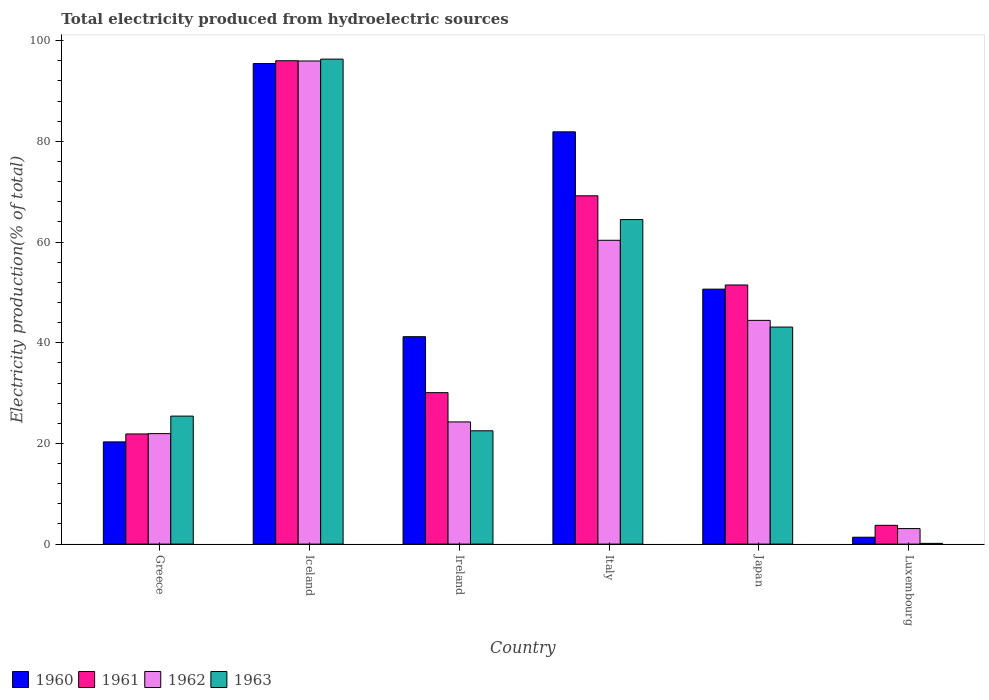How many different coloured bars are there?
Give a very brief answer. 4. Are the number of bars per tick equal to the number of legend labels?
Provide a short and direct response. Yes. Are the number of bars on each tick of the X-axis equal?
Keep it short and to the point. Yes. How many bars are there on the 2nd tick from the left?
Give a very brief answer. 4. How many bars are there on the 3rd tick from the right?
Your response must be concise. 4. In how many cases, is the number of bars for a given country not equal to the number of legend labels?
Keep it short and to the point. 0. What is the total electricity produced in 1960 in Italy?
Offer a terse response. 81.9. Across all countries, what is the maximum total electricity produced in 1962?
Ensure brevity in your answer.  95.97. Across all countries, what is the minimum total electricity produced in 1961?
Ensure brevity in your answer.  3.73. In which country was the total electricity produced in 1960 minimum?
Make the answer very short. Luxembourg. What is the total total electricity produced in 1961 in the graph?
Offer a terse response. 272.39. What is the difference between the total electricity produced in 1960 in Greece and that in Luxembourg?
Keep it short and to the point. 18.94. What is the difference between the total electricity produced in 1961 in Italy and the total electricity produced in 1960 in Luxembourg?
Make the answer very short. 67.82. What is the average total electricity produced in 1962 per country?
Provide a succinct answer. 41.68. What is the difference between the total electricity produced of/in 1960 and total electricity produced of/in 1961 in Japan?
Your answer should be very brief. -0.83. In how many countries, is the total electricity produced in 1960 greater than 68 %?
Provide a succinct answer. 2. What is the ratio of the total electricity produced in 1962 in Iceland to that in Japan?
Give a very brief answer. 2.16. Is the difference between the total electricity produced in 1960 in Ireland and Japan greater than the difference between the total electricity produced in 1961 in Ireland and Japan?
Keep it short and to the point. Yes. What is the difference between the highest and the second highest total electricity produced in 1963?
Give a very brief answer. 53.23. What is the difference between the highest and the lowest total electricity produced in 1963?
Ensure brevity in your answer.  96.19. In how many countries, is the total electricity produced in 1961 greater than the average total electricity produced in 1961 taken over all countries?
Your answer should be very brief. 3. Is the sum of the total electricity produced in 1962 in Iceland and Luxembourg greater than the maximum total electricity produced in 1963 across all countries?
Make the answer very short. Yes. What does the 3rd bar from the right in Japan represents?
Your answer should be compact. 1961. How many bars are there?
Your response must be concise. 24. Are all the bars in the graph horizontal?
Offer a terse response. No. What is the difference between two consecutive major ticks on the Y-axis?
Provide a succinct answer. 20. Are the values on the major ticks of Y-axis written in scientific E-notation?
Offer a very short reply. No. Does the graph contain grids?
Keep it short and to the point. No. Where does the legend appear in the graph?
Your response must be concise. Bottom left. How are the legend labels stacked?
Your response must be concise. Horizontal. What is the title of the graph?
Your answer should be very brief. Total electricity produced from hydroelectric sources. Does "1963" appear as one of the legend labels in the graph?
Your response must be concise. Yes. What is the label or title of the Y-axis?
Your answer should be very brief. Electricity production(% of total). What is the Electricity production(% of total) of 1960 in Greece?
Provide a short and direct response. 20.31. What is the Electricity production(% of total) of 1961 in Greece?
Provide a succinct answer. 21.88. What is the Electricity production(% of total) of 1962 in Greece?
Make the answer very short. 21.95. What is the Electricity production(% of total) in 1963 in Greece?
Offer a terse response. 25.43. What is the Electricity production(% of total) of 1960 in Iceland?
Provide a succinct answer. 95.46. What is the Electricity production(% of total) of 1961 in Iceland?
Offer a terse response. 96.02. What is the Electricity production(% of total) of 1962 in Iceland?
Give a very brief answer. 95.97. What is the Electricity production(% of total) of 1963 in Iceland?
Your answer should be very brief. 96.34. What is the Electricity production(% of total) of 1960 in Ireland?
Your response must be concise. 41.2. What is the Electricity production(% of total) of 1961 in Ireland?
Your answer should be compact. 30.09. What is the Electricity production(% of total) in 1962 in Ireland?
Make the answer very short. 24.27. What is the Electricity production(% of total) of 1963 in Ireland?
Ensure brevity in your answer.  22.51. What is the Electricity production(% of total) of 1960 in Italy?
Your answer should be compact. 81.9. What is the Electricity production(% of total) in 1961 in Italy?
Offer a very short reply. 69.19. What is the Electricity production(% of total) in 1962 in Italy?
Offer a terse response. 60.35. What is the Electricity production(% of total) in 1963 in Italy?
Provide a succinct answer. 64.47. What is the Electricity production(% of total) of 1960 in Japan?
Your answer should be very brief. 50.65. What is the Electricity production(% of total) in 1961 in Japan?
Your answer should be very brief. 51.48. What is the Electricity production(% of total) in 1962 in Japan?
Keep it short and to the point. 44.44. What is the Electricity production(% of total) in 1963 in Japan?
Provide a succinct answer. 43.11. What is the Electricity production(% of total) in 1960 in Luxembourg?
Your answer should be compact. 1.37. What is the Electricity production(% of total) in 1961 in Luxembourg?
Provide a short and direct response. 3.73. What is the Electricity production(% of total) in 1962 in Luxembourg?
Offer a very short reply. 3.08. What is the Electricity production(% of total) of 1963 in Luxembourg?
Provide a short and direct response. 0.15. Across all countries, what is the maximum Electricity production(% of total) in 1960?
Offer a very short reply. 95.46. Across all countries, what is the maximum Electricity production(% of total) in 1961?
Offer a very short reply. 96.02. Across all countries, what is the maximum Electricity production(% of total) of 1962?
Your response must be concise. 95.97. Across all countries, what is the maximum Electricity production(% of total) of 1963?
Your answer should be compact. 96.34. Across all countries, what is the minimum Electricity production(% of total) in 1960?
Provide a succinct answer. 1.37. Across all countries, what is the minimum Electricity production(% of total) of 1961?
Provide a succinct answer. 3.73. Across all countries, what is the minimum Electricity production(% of total) of 1962?
Give a very brief answer. 3.08. Across all countries, what is the minimum Electricity production(% of total) of 1963?
Provide a succinct answer. 0.15. What is the total Electricity production(% of total) in 1960 in the graph?
Make the answer very short. 290.89. What is the total Electricity production(% of total) in 1961 in the graph?
Offer a terse response. 272.39. What is the total Electricity production(% of total) of 1962 in the graph?
Keep it short and to the point. 250.08. What is the total Electricity production(% of total) in 1963 in the graph?
Your response must be concise. 252.01. What is the difference between the Electricity production(% of total) of 1960 in Greece and that in Iceland?
Your answer should be very brief. -75.16. What is the difference between the Electricity production(% of total) of 1961 in Greece and that in Iceland?
Offer a terse response. -74.14. What is the difference between the Electricity production(% of total) of 1962 in Greece and that in Iceland?
Your answer should be very brief. -74.02. What is the difference between the Electricity production(% of total) of 1963 in Greece and that in Iceland?
Keep it short and to the point. -70.91. What is the difference between the Electricity production(% of total) in 1960 in Greece and that in Ireland?
Offer a terse response. -20.9. What is the difference between the Electricity production(% of total) of 1961 in Greece and that in Ireland?
Keep it short and to the point. -8.2. What is the difference between the Electricity production(% of total) in 1962 in Greece and that in Ireland?
Your answer should be compact. -2.32. What is the difference between the Electricity production(% of total) in 1963 in Greece and that in Ireland?
Your answer should be very brief. 2.92. What is the difference between the Electricity production(% of total) in 1960 in Greece and that in Italy?
Provide a short and direct response. -61.59. What is the difference between the Electricity production(% of total) of 1961 in Greece and that in Italy?
Your answer should be compact. -47.31. What is the difference between the Electricity production(% of total) in 1962 in Greece and that in Italy?
Keep it short and to the point. -38.4. What is the difference between the Electricity production(% of total) of 1963 in Greece and that in Italy?
Provide a succinct answer. -39.04. What is the difference between the Electricity production(% of total) of 1960 in Greece and that in Japan?
Make the answer very short. -30.34. What is the difference between the Electricity production(% of total) in 1961 in Greece and that in Japan?
Provide a short and direct response. -29.59. What is the difference between the Electricity production(% of total) in 1962 in Greece and that in Japan?
Make the answer very short. -22.49. What is the difference between the Electricity production(% of total) of 1963 in Greece and that in Japan?
Give a very brief answer. -17.69. What is the difference between the Electricity production(% of total) in 1960 in Greece and that in Luxembourg?
Offer a very short reply. 18.94. What is the difference between the Electricity production(% of total) in 1961 in Greece and that in Luxembourg?
Your response must be concise. 18.15. What is the difference between the Electricity production(% of total) of 1962 in Greece and that in Luxembourg?
Ensure brevity in your answer.  18.87. What is the difference between the Electricity production(% of total) of 1963 in Greece and that in Luxembourg?
Offer a terse response. 25.28. What is the difference between the Electricity production(% of total) in 1960 in Iceland and that in Ireland?
Your answer should be very brief. 54.26. What is the difference between the Electricity production(% of total) of 1961 in Iceland and that in Ireland?
Make the answer very short. 65.93. What is the difference between the Electricity production(% of total) of 1962 in Iceland and that in Ireland?
Your answer should be compact. 71.7. What is the difference between the Electricity production(% of total) of 1963 in Iceland and that in Ireland?
Your answer should be very brief. 73.83. What is the difference between the Electricity production(% of total) in 1960 in Iceland and that in Italy?
Ensure brevity in your answer.  13.56. What is the difference between the Electricity production(% of total) of 1961 in Iceland and that in Italy?
Offer a terse response. 26.83. What is the difference between the Electricity production(% of total) of 1962 in Iceland and that in Italy?
Your answer should be compact. 35.62. What is the difference between the Electricity production(% of total) in 1963 in Iceland and that in Italy?
Your answer should be compact. 31.87. What is the difference between the Electricity production(% of total) of 1960 in Iceland and that in Japan?
Give a very brief answer. 44.81. What is the difference between the Electricity production(% of total) of 1961 in Iceland and that in Japan?
Provide a short and direct response. 44.54. What is the difference between the Electricity production(% of total) of 1962 in Iceland and that in Japan?
Your answer should be compact. 51.53. What is the difference between the Electricity production(% of total) of 1963 in Iceland and that in Japan?
Give a very brief answer. 53.23. What is the difference between the Electricity production(% of total) in 1960 in Iceland and that in Luxembourg?
Provide a short and direct response. 94.1. What is the difference between the Electricity production(% of total) in 1961 in Iceland and that in Luxembourg?
Your answer should be compact. 92.29. What is the difference between the Electricity production(% of total) in 1962 in Iceland and that in Luxembourg?
Ensure brevity in your answer.  92.89. What is the difference between the Electricity production(% of total) of 1963 in Iceland and that in Luxembourg?
Provide a short and direct response. 96.19. What is the difference between the Electricity production(% of total) of 1960 in Ireland and that in Italy?
Offer a very short reply. -40.7. What is the difference between the Electricity production(% of total) of 1961 in Ireland and that in Italy?
Keep it short and to the point. -39.1. What is the difference between the Electricity production(% of total) of 1962 in Ireland and that in Italy?
Provide a succinct answer. -36.08. What is the difference between the Electricity production(% of total) in 1963 in Ireland and that in Italy?
Keep it short and to the point. -41.96. What is the difference between the Electricity production(% of total) of 1960 in Ireland and that in Japan?
Your response must be concise. -9.45. What is the difference between the Electricity production(% of total) of 1961 in Ireland and that in Japan?
Provide a short and direct response. -21.39. What is the difference between the Electricity production(% of total) of 1962 in Ireland and that in Japan?
Offer a terse response. -20.17. What is the difference between the Electricity production(% of total) in 1963 in Ireland and that in Japan?
Make the answer very short. -20.61. What is the difference between the Electricity production(% of total) in 1960 in Ireland and that in Luxembourg?
Offer a terse response. 39.84. What is the difference between the Electricity production(% of total) of 1961 in Ireland and that in Luxembourg?
Your answer should be very brief. 26.36. What is the difference between the Electricity production(% of total) of 1962 in Ireland and that in Luxembourg?
Your answer should be compact. 21.19. What is the difference between the Electricity production(% of total) in 1963 in Ireland and that in Luxembourg?
Make the answer very short. 22.36. What is the difference between the Electricity production(% of total) in 1960 in Italy and that in Japan?
Make the answer very short. 31.25. What is the difference between the Electricity production(% of total) in 1961 in Italy and that in Japan?
Provide a succinct answer. 17.71. What is the difference between the Electricity production(% of total) of 1962 in Italy and that in Japan?
Offer a terse response. 15.91. What is the difference between the Electricity production(% of total) of 1963 in Italy and that in Japan?
Make the answer very short. 21.35. What is the difference between the Electricity production(% of total) of 1960 in Italy and that in Luxembourg?
Your answer should be compact. 80.53. What is the difference between the Electricity production(% of total) of 1961 in Italy and that in Luxembourg?
Your answer should be compact. 65.46. What is the difference between the Electricity production(% of total) of 1962 in Italy and that in Luxembourg?
Your response must be concise. 57.27. What is the difference between the Electricity production(% of total) of 1963 in Italy and that in Luxembourg?
Make the answer very short. 64.32. What is the difference between the Electricity production(% of total) of 1960 in Japan and that in Luxembourg?
Keep it short and to the point. 49.28. What is the difference between the Electricity production(% of total) in 1961 in Japan and that in Luxembourg?
Ensure brevity in your answer.  47.75. What is the difference between the Electricity production(% of total) in 1962 in Japan and that in Luxembourg?
Provide a short and direct response. 41.36. What is the difference between the Electricity production(% of total) in 1963 in Japan and that in Luxembourg?
Offer a very short reply. 42.97. What is the difference between the Electricity production(% of total) in 1960 in Greece and the Electricity production(% of total) in 1961 in Iceland?
Ensure brevity in your answer.  -75.71. What is the difference between the Electricity production(% of total) in 1960 in Greece and the Electricity production(% of total) in 1962 in Iceland?
Offer a terse response. -75.67. What is the difference between the Electricity production(% of total) in 1960 in Greece and the Electricity production(% of total) in 1963 in Iceland?
Your answer should be very brief. -76.04. What is the difference between the Electricity production(% of total) of 1961 in Greece and the Electricity production(% of total) of 1962 in Iceland?
Offer a very short reply. -74.09. What is the difference between the Electricity production(% of total) of 1961 in Greece and the Electricity production(% of total) of 1963 in Iceland?
Provide a short and direct response. -74.46. What is the difference between the Electricity production(% of total) of 1962 in Greece and the Electricity production(% of total) of 1963 in Iceland?
Give a very brief answer. -74.39. What is the difference between the Electricity production(% of total) in 1960 in Greece and the Electricity production(% of total) in 1961 in Ireland?
Give a very brief answer. -9.78. What is the difference between the Electricity production(% of total) of 1960 in Greece and the Electricity production(% of total) of 1962 in Ireland?
Provide a short and direct response. -3.97. What is the difference between the Electricity production(% of total) of 1960 in Greece and the Electricity production(% of total) of 1963 in Ireland?
Offer a terse response. -2.2. What is the difference between the Electricity production(% of total) of 1961 in Greece and the Electricity production(% of total) of 1962 in Ireland?
Offer a very short reply. -2.39. What is the difference between the Electricity production(% of total) in 1961 in Greece and the Electricity production(% of total) in 1963 in Ireland?
Your response must be concise. -0.63. What is the difference between the Electricity production(% of total) in 1962 in Greece and the Electricity production(% of total) in 1963 in Ireland?
Provide a short and direct response. -0.56. What is the difference between the Electricity production(% of total) in 1960 in Greece and the Electricity production(% of total) in 1961 in Italy?
Offer a very short reply. -48.88. What is the difference between the Electricity production(% of total) of 1960 in Greece and the Electricity production(% of total) of 1962 in Italy?
Your answer should be compact. -40.05. What is the difference between the Electricity production(% of total) of 1960 in Greece and the Electricity production(% of total) of 1963 in Italy?
Give a very brief answer. -44.16. What is the difference between the Electricity production(% of total) of 1961 in Greece and the Electricity production(% of total) of 1962 in Italy?
Ensure brevity in your answer.  -38.47. What is the difference between the Electricity production(% of total) of 1961 in Greece and the Electricity production(% of total) of 1963 in Italy?
Give a very brief answer. -42.58. What is the difference between the Electricity production(% of total) of 1962 in Greece and the Electricity production(% of total) of 1963 in Italy?
Offer a terse response. -42.52. What is the difference between the Electricity production(% of total) in 1960 in Greece and the Electricity production(% of total) in 1961 in Japan?
Your response must be concise. -31.17. What is the difference between the Electricity production(% of total) of 1960 in Greece and the Electricity production(% of total) of 1962 in Japan?
Keep it short and to the point. -24.14. What is the difference between the Electricity production(% of total) of 1960 in Greece and the Electricity production(% of total) of 1963 in Japan?
Offer a terse response. -22.81. What is the difference between the Electricity production(% of total) in 1961 in Greece and the Electricity production(% of total) in 1962 in Japan?
Provide a succinct answer. -22.56. What is the difference between the Electricity production(% of total) of 1961 in Greece and the Electricity production(% of total) of 1963 in Japan?
Keep it short and to the point. -21.23. What is the difference between the Electricity production(% of total) in 1962 in Greece and the Electricity production(% of total) in 1963 in Japan?
Provide a short and direct response. -21.16. What is the difference between the Electricity production(% of total) of 1960 in Greece and the Electricity production(% of total) of 1961 in Luxembourg?
Your response must be concise. 16.58. What is the difference between the Electricity production(% of total) of 1960 in Greece and the Electricity production(% of total) of 1962 in Luxembourg?
Make the answer very short. 17.22. What is the difference between the Electricity production(% of total) in 1960 in Greece and the Electricity production(% of total) in 1963 in Luxembourg?
Provide a short and direct response. 20.16. What is the difference between the Electricity production(% of total) of 1961 in Greece and the Electricity production(% of total) of 1962 in Luxembourg?
Your answer should be compact. 18.8. What is the difference between the Electricity production(% of total) of 1961 in Greece and the Electricity production(% of total) of 1963 in Luxembourg?
Your answer should be very brief. 21.74. What is the difference between the Electricity production(% of total) of 1962 in Greece and the Electricity production(% of total) of 1963 in Luxembourg?
Your answer should be compact. 21.8. What is the difference between the Electricity production(% of total) in 1960 in Iceland and the Electricity production(% of total) in 1961 in Ireland?
Provide a succinct answer. 65.38. What is the difference between the Electricity production(% of total) in 1960 in Iceland and the Electricity production(% of total) in 1962 in Ireland?
Your response must be concise. 71.19. What is the difference between the Electricity production(% of total) of 1960 in Iceland and the Electricity production(% of total) of 1963 in Ireland?
Your answer should be compact. 72.95. What is the difference between the Electricity production(% of total) of 1961 in Iceland and the Electricity production(% of total) of 1962 in Ireland?
Ensure brevity in your answer.  71.75. What is the difference between the Electricity production(% of total) of 1961 in Iceland and the Electricity production(% of total) of 1963 in Ireland?
Offer a very short reply. 73.51. What is the difference between the Electricity production(% of total) in 1962 in Iceland and the Electricity production(% of total) in 1963 in Ireland?
Keep it short and to the point. 73.47. What is the difference between the Electricity production(% of total) in 1960 in Iceland and the Electricity production(% of total) in 1961 in Italy?
Your answer should be compact. 26.27. What is the difference between the Electricity production(% of total) in 1960 in Iceland and the Electricity production(% of total) in 1962 in Italy?
Keep it short and to the point. 35.11. What is the difference between the Electricity production(% of total) of 1960 in Iceland and the Electricity production(% of total) of 1963 in Italy?
Provide a succinct answer. 30.99. What is the difference between the Electricity production(% of total) in 1961 in Iceland and the Electricity production(% of total) in 1962 in Italy?
Give a very brief answer. 35.67. What is the difference between the Electricity production(% of total) of 1961 in Iceland and the Electricity production(% of total) of 1963 in Italy?
Offer a terse response. 31.55. What is the difference between the Electricity production(% of total) in 1962 in Iceland and the Electricity production(% of total) in 1963 in Italy?
Ensure brevity in your answer.  31.51. What is the difference between the Electricity production(% of total) of 1960 in Iceland and the Electricity production(% of total) of 1961 in Japan?
Keep it short and to the point. 43.99. What is the difference between the Electricity production(% of total) in 1960 in Iceland and the Electricity production(% of total) in 1962 in Japan?
Make the answer very short. 51.02. What is the difference between the Electricity production(% of total) of 1960 in Iceland and the Electricity production(% of total) of 1963 in Japan?
Your answer should be compact. 52.35. What is the difference between the Electricity production(% of total) in 1961 in Iceland and the Electricity production(% of total) in 1962 in Japan?
Provide a succinct answer. 51.58. What is the difference between the Electricity production(% of total) of 1961 in Iceland and the Electricity production(% of total) of 1963 in Japan?
Make the answer very short. 52.91. What is the difference between the Electricity production(% of total) of 1962 in Iceland and the Electricity production(% of total) of 1963 in Japan?
Your response must be concise. 52.86. What is the difference between the Electricity production(% of total) in 1960 in Iceland and the Electricity production(% of total) in 1961 in Luxembourg?
Your answer should be compact. 91.73. What is the difference between the Electricity production(% of total) of 1960 in Iceland and the Electricity production(% of total) of 1962 in Luxembourg?
Offer a terse response. 92.38. What is the difference between the Electricity production(% of total) of 1960 in Iceland and the Electricity production(% of total) of 1963 in Luxembourg?
Keep it short and to the point. 95.32. What is the difference between the Electricity production(% of total) in 1961 in Iceland and the Electricity production(% of total) in 1962 in Luxembourg?
Ensure brevity in your answer.  92.94. What is the difference between the Electricity production(% of total) in 1961 in Iceland and the Electricity production(% of total) in 1963 in Luxembourg?
Ensure brevity in your answer.  95.87. What is the difference between the Electricity production(% of total) of 1962 in Iceland and the Electricity production(% of total) of 1963 in Luxembourg?
Keep it short and to the point. 95.83. What is the difference between the Electricity production(% of total) in 1960 in Ireland and the Electricity production(% of total) in 1961 in Italy?
Provide a succinct answer. -27.99. What is the difference between the Electricity production(% of total) of 1960 in Ireland and the Electricity production(% of total) of 1962 in Italy?
Give a very brief answer. -19.15. What is the difference between the Electricity production(% of total) in 1960 in Ireland and the Electricity production(% of total) in 1963 in Italy?
Offer a terse response. -23.27. What is the difference between the Electricity production(% of total) of 1961 in Ireland and the Electricity production(% of total) of 1962 in Italy?
Ensure brevity in your answer.  -30.27. What is the difference between the Electricity production(% of total) in 1961 in Ireland and the Electricity production(% of total) in 1963 in Italy?
Provide a succinct answer. -34.38. What is the difference between the Electricity production(% of total) in 1962 in Ireland and the Electricity production(% of total) in 1963 in Italy?
Your answer should be very brief. -40.2. What is the difference between the Electricity production(% of total) in 1960 in Ireland and the Electricity production(% of total) in 1961 in Japan?
Offer a very short reply. -10.27. What is the difference between the Electricity production(% of total) in 1960 in Ireland and the Electricity production(% of total) in 1962 in Japan?
Provide a short and direct response. -3.24. What is the difference between the Electricity production(% of total) of 1960 in Ireland and the Electricity production(% of total) of 1963 in Japan?
Offer a very short reply. -1.91. What is the difference between the Electricity production(% of total) in 1961 in Ireland and the Electricity production(% of total) in 1962 in Japan?
Your answer should be very brief. -14.36. What is the difference between the Electricity production(% of total) in 1961 in Ireland and the Electricity production(% of total) in 1963 in Japan?
Provide a short and direct response. -13.03. What is the difference between the Electricity production(% of total) in 1962 in Ireland and the Electricity production(% of total) in 1963 in Japan?
Give a very brief answer. -18.84. What is the difference between the Electricity production(% of total) of 1960 in Ireland and the Electricity production(% of total) of 1961 in Luxembourg?
Ensure brevity in your answer.  37.47. What is the difference between the Electricity production(% of total) of 1960 in Ireland and the Electricity production(% of total) of 1962 in Luxembourg?
Ensure brevity in your answer.  38.12. What is the difference between the Electricity production(% of total) in 1960 in Ireland and the Electricity production(% of total) in 1963 in Luxembourg?
Ensure brevity in your answer.  41.05. What is the difference between the Electricity production(% of total) of 1961 in Ireland and the Electricity production(% of total) of 1962 in Luxembourg?
Ensure brevity in your answer.  27. What is the difference between the Electricity production(% of total) in 1961 in Ireland and the Electricity production(% of total) in 1963 in Luxembourg?
Keep it short and to the point. 29.94. What is the difference between the Electricity production(% of total) in 1962 in Ireland and the Electricity production(% of total) in 1963 in Luxembourg?
Offer a very short reply. 24.12. What is the difference between the Electricity production(% of total) of 1960 in Italy and the Electricity production(% of total) of 1961 in Japan?
Your answer should be compact. 30.42. What is the difference between the Electricity production(% of total) of 1960 in Italy and the Electricity production(% of total) of 1962 in Japan?
Make the answer very short. 37.46. What is the difference between the Electricity production(% of total) of 1960 in Italy and the Electricity production(% of total) of 1963 in Japan?
Your answer should be compact. 38.79. What is the difference between the Electricity production(% of total) in 1961 in Italy and the Electricity production(% of total) in 1962 in Japan?
Your response must be concise. 24.75. What is the difference between the Electricity production(% of total) of 1961 in Italy and the Electricity production(% of total) of 1963 in Japan?
Your answer should be compact. 26.08. What is the difference between the Electricity production(% of total) of 1962 in Italy and the Electricity production(% of total) of 1963 in Japan?
Offer a very short reply. 17.24. What is the difference between the Electricity production(% of total) of 1960 in Italy and the Electricity production(% of total) of 1961 in Luxembourg?
Your response must be concise. 78.17. What is the difference between the Electricity production(% of total) in 1960 in Italy and the Electricity production(% of total) in 1962 in Luxembourg?
Your response must be concise. 78.82. What is the difference between the Electricity production(% of total) of 1960 in Italy and the Electricity production(% of total) of 1963 in Luxembourg?
Your answer should be compact. 81.75. What is the difference between the Electricity production(% of total) of 1961 in Italy and the Electricity production(% of total) of 1962 in Luxembourg?
Give a very brief answer. 66.11. What is the difference between the Electricity production(% of total) of 1961 in Italy and the Electricity production(% of total) of 1963 in Luxembourg?
Your answer should be very brief. 69.04. What is the difference between the Electricity production(% of total) of 1962 in Italy and the Electricity production(% of total) of 1963 in Luxembourg?
Your answer should be very brief. 60.21. What is the difference between the Electricity production(% of total) in 1960 in Japan and the Electricity production(% of total) in 1961 in Luxembourg?
Your answer should be compact. 46.92. What is the difference between the Electricity production(% of total) of 1960 in Japan and the Electricity production(% of total) of 1962 in Luxembourg?
Your response must be concise. 47.57. What is the difference between the Electricity production(% of total) of 1960 in Japan and the Electricity production(% of total) of 1963 in Luxembourg?
Your answer should be very brief. 50.5. What is the difference between the Electricity production(% of total) of 1961 in Japan and the Electricity production(% of total) of 1962 in Luxembourg?
Keep it short and to the point. 48.39. What is the difference between the Electricity production(% of total) in 1961 in Japan and the Electricity production(% of total) in 1963 in Luxembourg?
Your response must be concise. 51.33. What is the difference between the Electricity production(% of total) of 1962 in Japan and the Electricity production(% of total) of 1963 in Luxembourg?
Give a very brief answer. 44.3. What is the average Electricity production(% of total) in 1960 per country?
Your response must be concise. 48.48. What is the average Electricity production(% of total) in 1961 per country?
Make the answer very short. 45.4. What is the average Electricity production(% of total) in 1962 per country?
Give a very brief answer. 41.68. What is the average Electricity production(% of total) of 1963 per country?
Your response must be concise. 42. What is the difference between the Electricity production(% of total) of 1960 and Electricity production(% of total) of 1961 in Greece?
Offer a very short reply. -1.58. What is the difference between the Electricity production(% of total) of 1960 and Electricity production(% of total) of 1962 in Greece?
Ensure brevity in your answer.  -1.64. What is the difference between the Electricity production(% of total) in 1960 and Electricity production(% of total) in 1963 in Greece?
Your response must be concise. -5.12. What is the difference between the Electricity production(% of total) in 1961 and Electricity production(% of total) in 1962 in Greece?
Offer a very short reply. -0.07. What is the difference between the Electricity production(% of total) of 1961 and Electricity production(% of total) of 1963 in Greece?
Offer a terse response. -3.54. What is the difference between the Electricity production(% of total) of 1962 and Electricity production(% of total) of 1963 in Greece?
Provide a short and direct response. -3.48. What is the difference between the Electricity production(% of total) of 1960 and Electricity production(% of total) of 1961 in Iceland?
Your answer should be compact. -0.56. What is the difference between the Electricity production(% of total) in 1960 and Electricity production(% of total) in 1962 in Iceland?
Offer a very short reply. -0.51. What is the difference between the Electricity production(% of total) of 1960 and Electricity production(% of total) of 1963 in Iceland?
Provide a succinct answer. -0.88. What is the difference between the Electricity production(% of total) in 1961 and Electricity production(% of total) in 1962 in Iceland?
Offer a terse response. 0.05. What is the difference between the Electricity production(% of total) in 1961 and Electricity production(% of total) in 1963 in Iceland?
Make the answer very short. -0.32. What is the difference between the Electricity production(% of total) in 1962 and Electricity production(% of total) in 1963 in Iceland?
Offer a very short reply. -0.37. What is the difference between the Electricity production(% of total) in 1960 and Electricity production(% of total) in 1961 in Ireland?
Provide a succinct answer. 11.12. What is the difference between the Electricity production(% of total) in 1960 and Electricity production(% of total) in 1962 in Ireland?
Give a very brief answer. 16.93. What is the difference between the Electricity production(% of total) of 1960 and Electricity production(% of total) of 1963 in Ireland?
Keep it short and to the point. 18.69. What is the difference between the Electricity production(% of total) in 1961 and Electricity production(% of total) in 1962 in Ireland?
Your answer should be compact. 5.81. What is the difference between the Electricity production(% of total) in 1961 and Electricity production(% of total) in 1963 in Ireland?
Give a very brief answer. 7.58. What is the difference between the Electricity production(% of total) of 1962 and Electricity production(% of total) of 1963 in Ireland?
Provide a succinct answer. 1.76. What is the difference between the Electricity production(% of total) of 1960 and Electricity production(% of total) of 1961 in Italy?
Your response must be concise. 12.71. What is the difference between the Electricity production(% of total) in 1960 and Electricity production(% of total) in 1962 in Italy?
Offer a terse response. 21.55. What is the difference between the Electricity production(% of total) of 1960 and Electricity production(% of total) of 1963 in Italy?
Keep it short and to the point. 17.43. What is the difference between the Electricity production(% of total) of 1961 and Electricity production(% of total) of 1962 in Italy?
Ensure brevity in your answer.  8.84. What is the difference between the Electricity production(% of total) in 1961 and Electricity production(% of total) in 1963 in Italy?
Offer a terse response. 4.72. What is the difference between the Electricity production(% of total) in 1962 and Electricity production(% of total) in 1963 in Italy?
Provide a short and direct response. -4.11. What is the difference between the Electricity production(% of total) of 1960 and Electricity production(% of total) of 1961 in Japan?
Make the answer very short. -0.83. What is the difference between the Electricity production(% of total) in 1960 and Electricity production(% of total) in 1962 in Japan?
Offer a very short reply. 6.2. What is the difference between the Electricity production(% of total) in 1960 and Electricity production(% of total) in 1963 in Japan?
Keep it short and to the point. 7.54. What is the difference between the Electricity production(% of total) in 1961 and Electricity production(% of total) in 1962 in Japan?
Your answer should be very brief. 7.03. What is the difference between the Electricity production(% of total) of 1961 and Electricity production(% of total) of 1963 in Japan?
Make the answer very short. 8.36. What is the difference between the Electricity production(% of total) of 1962 and Electricity production(% of total) of 1963 in Japan?
Offer a very short reply. 1.33. What is the difference between the Electricity production(% of total) in 1960 and Electricity production(% of total) in 1961 in Luxembourg?
Offer a very short reply. -2.36. What is the difference between the Electricity production(% of total) in 1960 and Electricity production(% of total) in 1962 in Luxembourg?
Keep it short and to the point. -1.72. What is the difference between the Electricity production(% of total) in 1960 and Electricity production(% of total) in 1963 in Luxembourg?
Give a very brief answer. 1.22. What is the difference between the Electricity production(% of total) of 1961 and Electricity production(% of total) of 1962 in Luxembourg?
Offer a terse response. 0.65. What is the difference between the Electricity production(% of total) of 1961 and Electricity production(% of total) of 1963 in Luxembourg?
Give a very brief answer. 3.58. What is the difference between the Electricity production(% of total) of 1962 and Electricity production(% of total) of 1963 in Luxembourg?
Provide a succinct answer. 2.93. What is the ratio of the Electricity production(% of total) in 1960 in Greece to that in Iceland?
Offer a terse response. 0.21. What is the ratio of the Electricity production(% of total) of 1961 in Greece to that in Iceland?
Provide a short and direct response. 0.23. What is the ratio of the Electricity production(% of total) in 1962 in Greece to that in Iceland?
Your response must be concise. 0.23. What is the ratio of the Electricity production(% of total) in 1963 in Greece to that in Iceland?
Provide a short and direct response. 0.26. What is the ratio of the Electricity production(% of total) of 1960 in Greece to that in Ireland?
Keep it short and to the point. 0.49. What is the ratio of the Electricity production(% of total) in 1961 in Greece to that in Ireland?
Offer a very short reply. 0.73. What is the ratio of the Electricity production(% of total) in 1962 in Greece to that in Ireland?
Give a very brief answer. 0.9. What is the ratio of the Electricity production(% of total) of 1963 in Greece to that in Ireland?
Offer a terse response. 1.13. What is the ratio of the Electricity production(% of total) of 1960 in Greece to that in Italy?
Provide a succinct answer. 0.25. What is the ratio of the Electricity production(% of total) in 1961 in Greece to that in Italy?
Make the answer very short. 0.32. What is the ratio of the Electricity production(% of total) in 1962 in Greece to that in Italy?
Your answer should be compact. 0.36. What is the ratio of the Electricity production(% of total) of 1963 in Greece to that in Italy?
Keep it short and to the point. 0.39. What is the ratio of the Electricity production(% of total) of 1960 in Greece to that in Japan?
Your answer should be very brief. 0.4. What is the ratio of the Electricity production(% of total) in 1961 in Greece to that in Japan?
Provide a succinct answer. 0.43. What is the ratio of the Electricity production(% of total) of 1962 in Greece to that in Japan?
Provide a short and direct response. 0.49. What is the ratio of the Electricity production(% of total) of 1963 in Greece to that in Japan?
Give a very brief answer. 0.59. What is the ratio of the Electricity production(% of total) of 1960 in Greece to that in Luxembourg?
Your response must be concise. 14.86. What is the ratio of the Electricity production(% of total) of 1961 in Greece to that in Luxembourg?
Provide a succinct answer. 5.87. What is the ratio of the Electricity production(% of total) in 1962 in Greece to that in Luxembourg?
Offer a terse response. 7.12. What is the ratio of the Electricity production(% of total) in 1963 in Greece to that in Luxembourg?
Provide a succinct answer. 172.27. What is the ratio of the Electricity production(% of total) in 1960 in Iceland to that in Ireland?
Offer a terse response. 2.32. What is the ratio of the Electricity production(% of total) in 1961 in Iceland to that in Ireland?
Provide a short and direct response. 3.19. What is the ratio of the Electricity production(% of total) of 1962 in Iceland to that in Ireland?
Your response must be concise. 3.95. What is the ratio of the Electricity production(% of total) of 1963 in Iceland to that in Ireland?
Provide a short and direct response. 4.28. What is the ratio of the Electricity production(% of total) in 1960 in Iceland to that in Italy?
Offer a terse response. 1.17. What is the ratio of the Electricity production(% of total) of 1961 in Iceland to that in Italy?
Your answer should be very brief. 1.39. What is the ratio of the Electricity production(% of total) in 1962 in Iceland to that in Italy?
Ensure brevity in your answer.  1.59. What is the ratio of the Electricity production(% of total) of 1963 in Iceland to that in Italy?
Ensure brevity in your answer.  1.49. What is the ratio of the Electricity production(% of total) of 1960 in Iceland to that in Japan?
Ensure brevity in your answer.  1.88. What is the ratio of the Electricity production(% of total) of 1961 in Iceland to that in Japan?
Ensure brevity in your answer.  1.87. What is the ratio of the Electricity production(% of total) in 1962 in Iceland to that in Japan?
Provide a short and direct response. 2.16. What is the ratio of the Electricity production(% of total) of 1963 in Iceland to that in Japan?
Your answer should be compact. 2.23. What is the ratio of the Electricity production(% of total) in 1960 in Iceland to that in Luxembourg?
Your response must be concise. 69.88. What is the ratio of the Electricity production(% of total) of 1961 in Iceland to that in Luxembourg?
Give a very brief answer. 25.74. What is the ratio of the Electricity production(% of total) in 1962 in Iceland to that in Luxembourg?
Keep it short and to the point. 31.14. What is the ratio of the Electricity production(% of total) in 1963 in Iceland to that in Luxembourg?
Keep it short and to the point. 652.71. What is the ratio of the Electricity production(% of total) in 1960 in Ireland to that in Italy?
Make the answer very short. 0.5. What is the ratio of the Electricity production(% of total) in 1961 in Ireland to that in Italy?
Your answer should be compact. 0.43. What is the ratio of the Electricity production(% of total) of 1962 in Ireland to that in Italy?
Your answer should be compact. 0.4. What is the ratio of the Electricity production(% of total) in 1963 in Ireland to that in Italy?
Offer a very short reply. 0.35. What is the ratio of the Electricity production(% of total) of 1960 in Ireland to that in Japan?
Offer a terse response. 0.81. What is the ratio of the Electricity production(% of total) in 1961 in Ireland to that in Japan?
Provide a succinct answer. 0.58. What is the ratio of the Electricity production(% of total) of 1962 in Ireland to that in Japan?
Make the answer very short. 0.55. What is the ratio of the Electricity production(% of total) in 1963 in Ireland to that in Japan?
Make the answer very short. 0.52. What is the ratio of the Electricity production(% of total) in 1960 in Ireland to that in Luxembourg?
Ensure brevity in your answer.  30.16. What is the ratio of the Electricity production(% of total) in 1961 in Ireland to that in Luxembourg?
Ensure brevity in your answer.  8.07. What is the ratio of the Electricity production(% of total) in 1962 in Ireland to that in Luxembourg?
Provide a short and direct response. 7.88. What is the ratio of the Electricity production(% of total) in 1963 in Ireland to that in Luxembourg?
Provide a short and direct response. 152.5. What is the ratio of the Electricity production(% of total) of 1960 in Italy to that in Japan?
Ensure brevity in your answer.  1.62. What is the ratio of the Electricity production(% of total) of 1961 in Italy to that in Japan?
Offer a very short reply. 1.34. What is the ratio of the Electricity production(% of total) of 1962 in Italy to that in Japan?
Offer a very short reply. 1.36. What is the ratio of the Electricity production(% of total) in 1963 in Italy to that in Japan?
Ensure brevity in your answer.  1.5. What is the ratio of the Electricity production(% of total) in 1960 in Italy to that in Luxembourg?
Your answer should be compact. 59.95. What is the ratio of the Electricity production(% of total) in 1961 in Italy to that in Luxembourg?
Keep it short and to the point. 18.55. What is the ratio of the Electricity production(% of total) in 1962 in Italy to that in Luxembourg?
Ensure brevity in your answer.  19.58. What is the ratio of the Electricity production(% of total) of 1963 in Italy to that in Luxembourg?
Your response must be concise. 436.77. What is the ratio of the Electricity production(% of total) of 1960 in Japan to that in Luxembourg?
Your answer should be very brief. 37.08. What is the ratio of the Electricity production(% of total) in 1961 in Japan to that in Luxembourg?
Your answer should be compact. 13.8. What is the ratio of the Electricity production(% of total) of 1962 in Japan to that in Luxembourg?
Offer a terse response. 14.42. What is the ratio of the Electricity production(% of total) in 1963 in Japan to that in Luxembourg?
Your response must be concise. 292.1. What is the difference between the highest and the second highest Electricity production(% of total) in 1960?
Ensure brevity in your answer.  13.56. What is the difference between the highest and the second highest Electricity production(% of total) of 1961?
Keep it short and to the point. 26.83. What is the difference between the highest and the second highest Electricity production(% of total) of 1962?
Provide a short and direct response. 35.62. What is the difference between the highest and the second highest Electricity production(% of total) of 1963?
Your response must be concise. 31.87. What is the difference between the highest and the lowest Electricity production(% of total) of 1960?
Provide a succinct answer. 94.1. What is the difference between the highest and the lowest Electricity production(% of total) of 1961?
Offer a terse response. 92.29. What is the difference between the highest and the lowest Electricity production(% of total) of 1962?
Provide a succinct answer. 92.89. What is the difference between the highest and the lowest Electricity production(% of total) of 1963?
Make the answer very short. 96.19. 